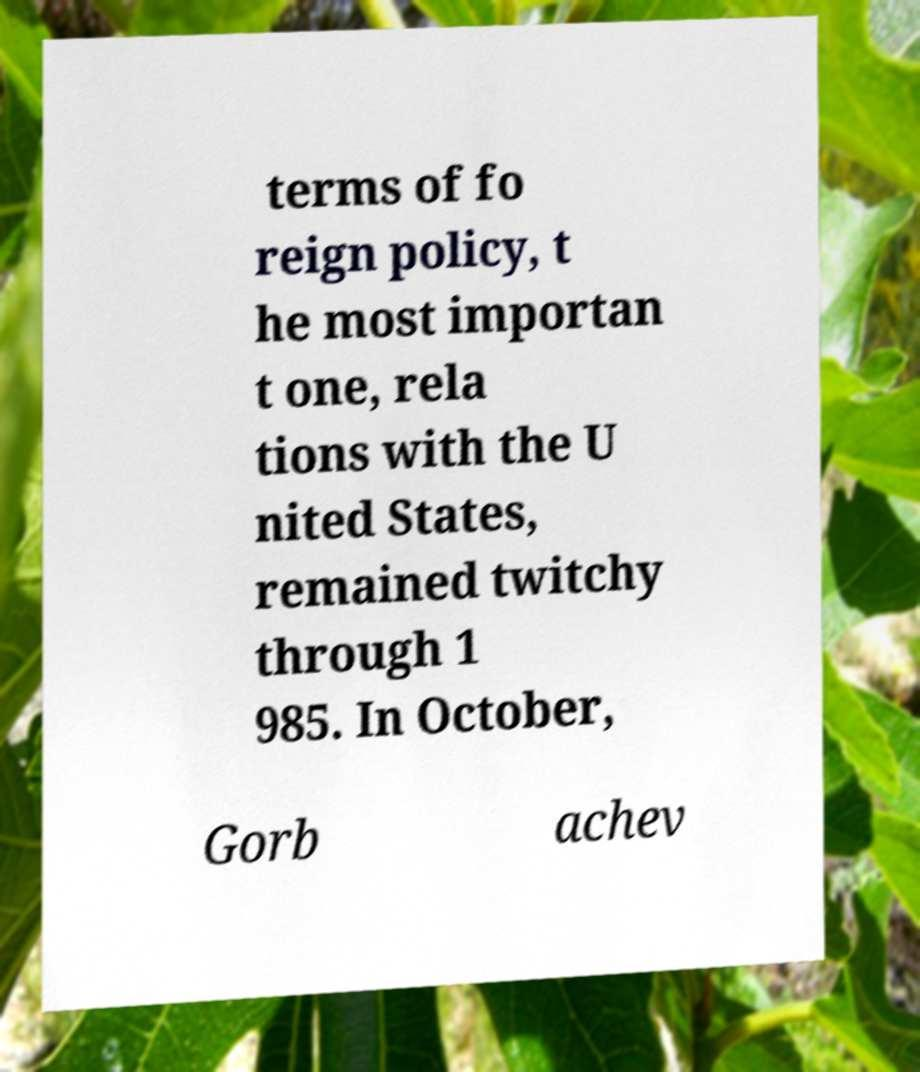Can you read and provide the text displayed in the image?This photo seems to have some interesting text. Can you extract and type it out for me? terms of fo reign policy, t he most importan t one, rela tions with the U nited States, remained twitchy through 1 985. In October, Gorb achev 